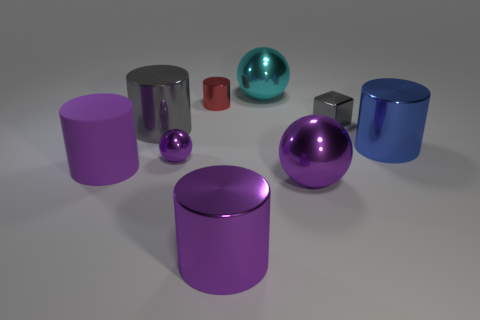What shape is the object that is both right of the large purple ball and left of the large blue cylinder?
Offer a very short reply. Cube. The tiny shiny object that is the same color as the matte thing is what shape?
Offer a very short reply. Sphere. What is the color of the tiny cube?
Ensure brevity in your answer.  Gray. There is a gray shiny thing that is to the left of the small ball; is it the same shape as the cyan thing?
Offer a terse response. No. What number of objects are purple balls that are in front of the red metal cylinder or large green rubber cylinders?
Offer a very short reply. 2. Is there a blue object of the same shape as the red object?
Provide a short and direct response. Yes. The cyan metal thing that is the same size as the blue shiny cylinder is what shape?
Offer a terse response. Sphere. The purple object to the left of the purple sphere behind the big sphere in front of the small shiny block is what shape?
Keep it short and to the point. Cylinder. There is a large blue metallic thing; does it have the same shape as the purple thing that is in front of the large purple metallic ball?
Keep it short and to the point. Yes. What number of small things are cyan spheres or blue objects?
Your answer should be very brief. 0. 